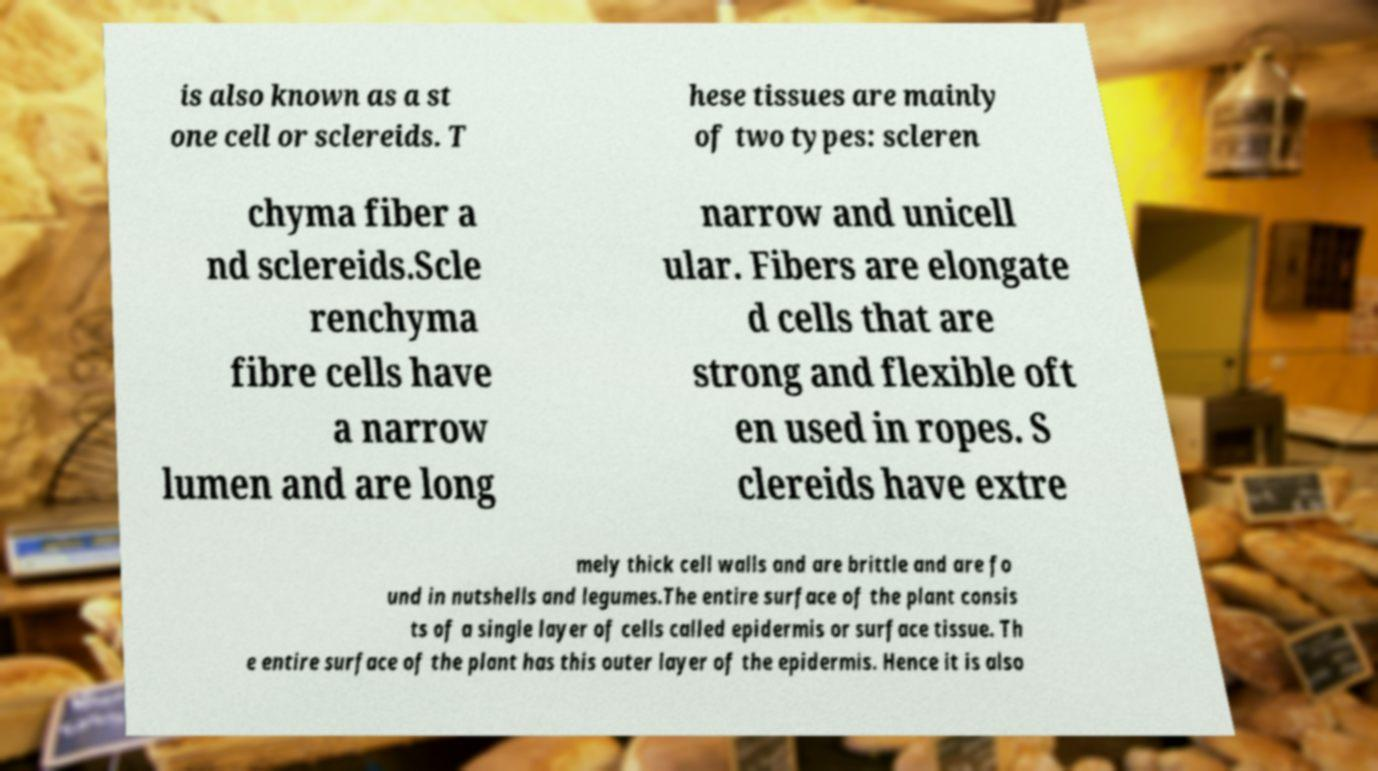Could you assist in decoding the text presented in this image and type it out clearly? is also known as a st one cell or sclereids. T hese tissues are mainly of two types: scleren chyma fiber a nd sclereids.Scle renchyma fibre cells have a narrow lumen and are long narrow and unicell ular. Fibers are elongate d cells that are strong and flexible oft en used in ropes. S clereids have extre mely thick cell walls and are brittle and are fo und in nutshells and legumes.The entire surface of the plant consis ts of a single layer of cells called epidermis or surface tissue. Th e entire surface of the plant has this outer layer of the epidermis. Hence it is also 